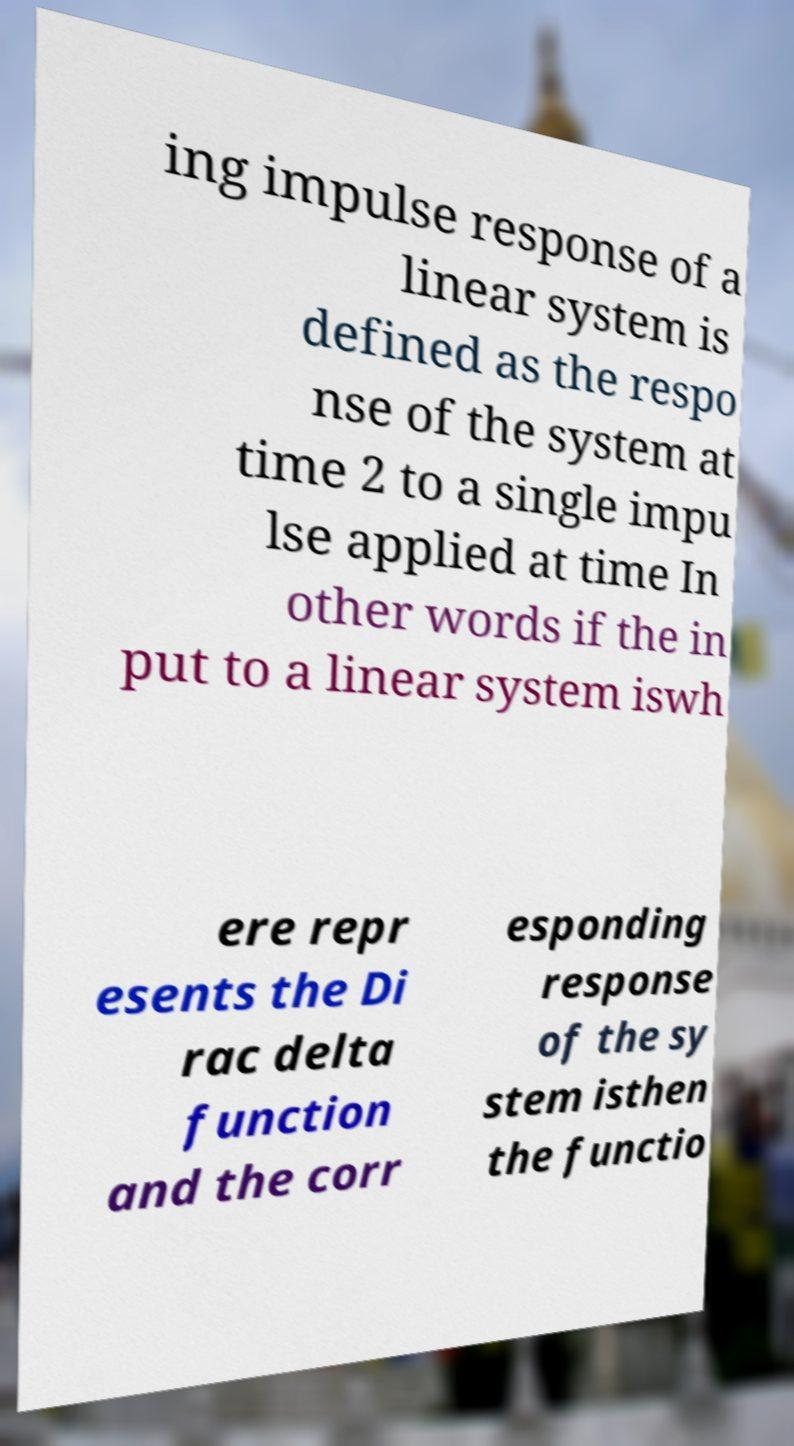Please identify and transcribe the text found in this image. ing impulse response of a linear system is defined as the respo nse of the system at time 2 to a single impu lse applied at time In other words if the in put to a linear system iswh ere repr esents the Di rac delta function and the corr esponding response of the sy stem isthen the functio 